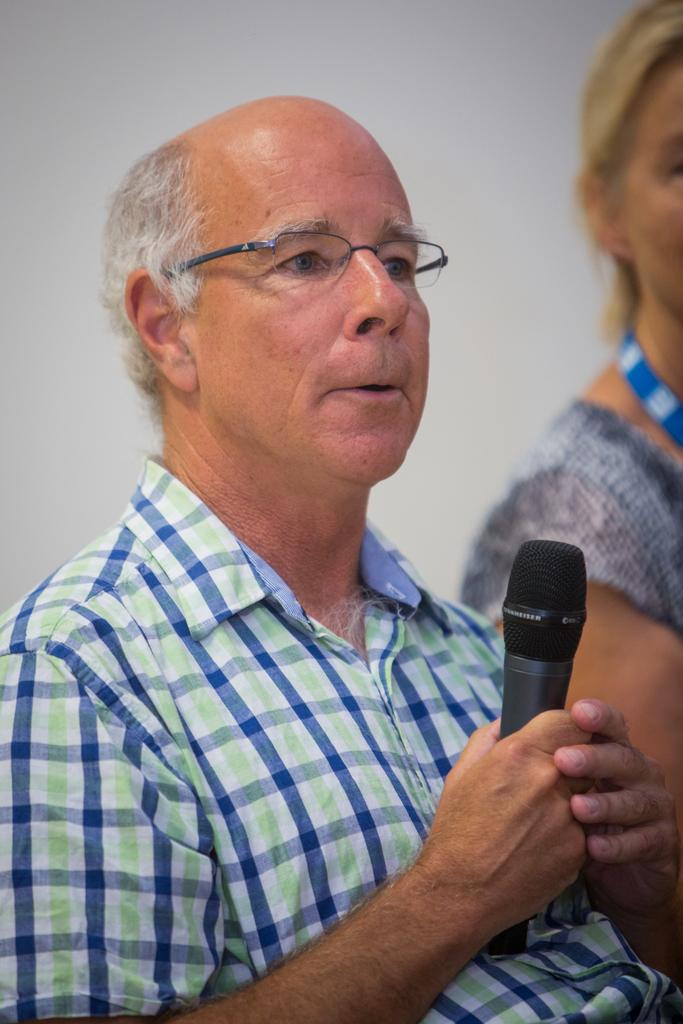What is the main subject in the foreground of the image? There is a person in the foreground of the image. What can be observed about the person's appearance? The person is wearing spectacles. What is the person holding in the image? The person is holding a microphone. Can you describe the woman on the right side of the image? There is a woman on the right side of the image. What is the color of the background in the image? The background of the image is white. What type of jewel is the actor wearing in the image? There is no actor or jewel present in the image. What part of the image is the most important? The entire image is important, as it contains multiple subjects and objects. 